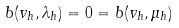<formula> <loc_0><loc_0><loc_500><loc_500>b ( v _ { h } , \lambda _ { h } ) = 0 = b ( v _ { h } , \mu _ { h } )</formula> 